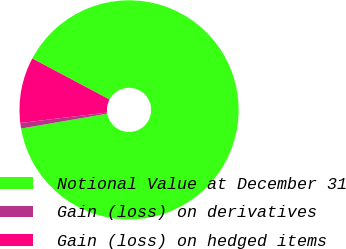Convert chart to OTSL. <chart><loc_0><loc_0><loc_500><loc_500><pie_chart><fcel>Notional Value at December 31<fcel>Gain (loss) on derivatives<fcel>Gain (loss) on hedged items<nl><fcel>89.52%<fcel>0.81%<fcel>9.68%<nl></chart> 